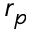<formula> <loc_0><loc_0><loc_500><loc_500>r _ { p }</formula> 